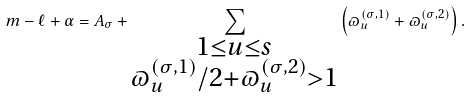Convert formula to latex. <formula><loc_0><loc_0><loc_500><loc_500>m - \ell + \alpha = A _ { \sigma } + \sum _ { \substack { 1 \leq u \leq s \\ \varpi _ { u } ^ { ( \sigma , 1 ) } / 2 + \varpi _ { u } ^ { ( \sigma , 2 ) } > 1 } } \left ( \varpi _ { u } ^ { ( \sigma , 1 ) } + \varpi _ { u } ^ { ( \sigma , 2 ) } \right ) .</formula> 